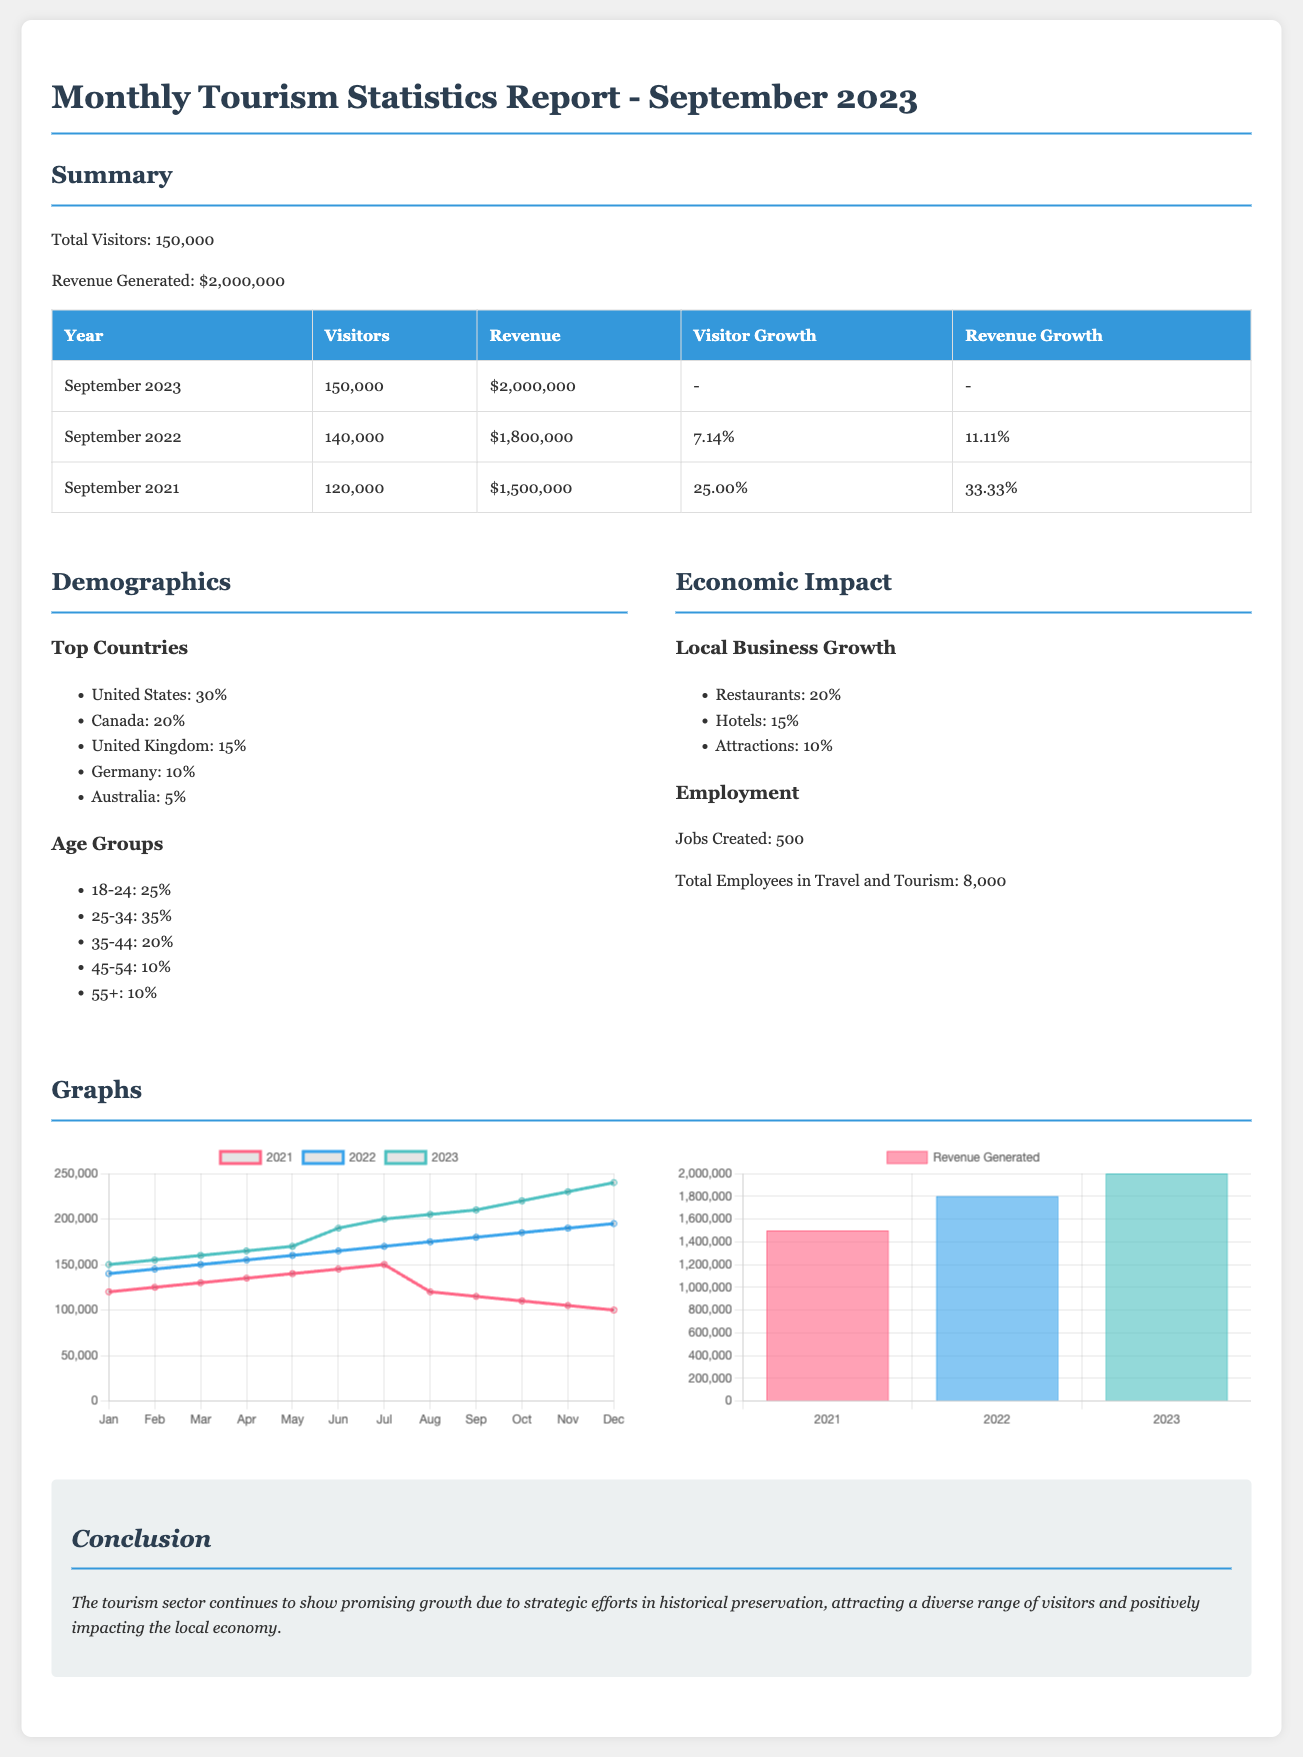What is the total number of visitors in September 2023? The total number of visitors reported for September 2023 is directly provided in the summary section of the document.
Answer: 150,000 What was the revenue generated in September 2022? The revenue generated in September 2022 can be found in the revenue table, which shows the corresponding revenue for last year.
Answer: $1,800,000 How much did visitor numbers grow from September 2021 to September 2022? The visitor growth percentage between September 2021 and September 2022 is specified in the percentage change column of the table.
Answer: 7.14% Which country contributed the highest percentage of visitors? The demographics section lists the top countries by percentage, with the United States having the highest contribution.
Answer: United States How many jobs were created in the tourism sector? The economic impact section provides the number of jobs created, reflecting the growth of the tourism sector.
Answer: 500 What type of chart represents revenue generated over the years? The type of chart used to visualize revenue generated over years is specified in the graphs section.
Answer: Bar What percentage of visitors are aged 25-34? The demographics section provides age group percentages, specifically indicating the portion of visitors aged 25-34.
Answer: 35% What does the conclusion emphasize about the tourism sector? The conclusion summarizes the impacts of historical preservation on tourism and its benefits mentioned in the report.
Answer: Growth How many total employees are in travel and tourism? The economic impact section states the total number of employees in the travel and tourism industry.
Answer: 8,000 